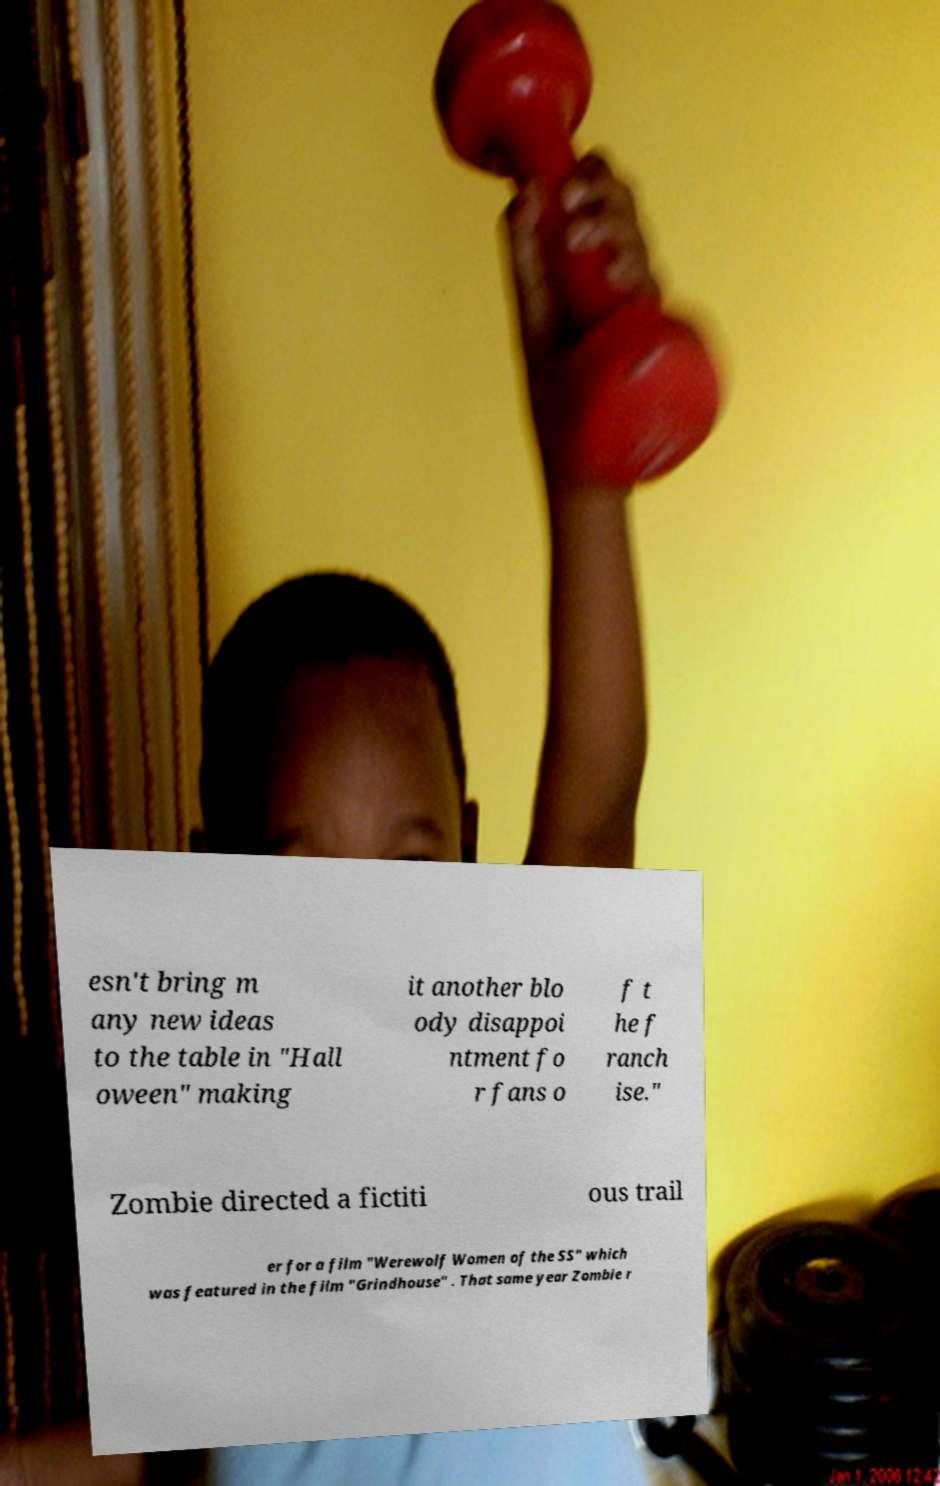There's text embedded in this image that I need extracted. Can you transcribe it verbatim? esn't bring m any new ideas to the table in "Hall oween" making it another blo ody disappoi ntment fo r fans o f t he f ranch ise." Zombie directed a fictiti ous trail er for a film "Werewolf Women of the SS" which was featured in the film "Grindhouse" . That same year Zombie r 